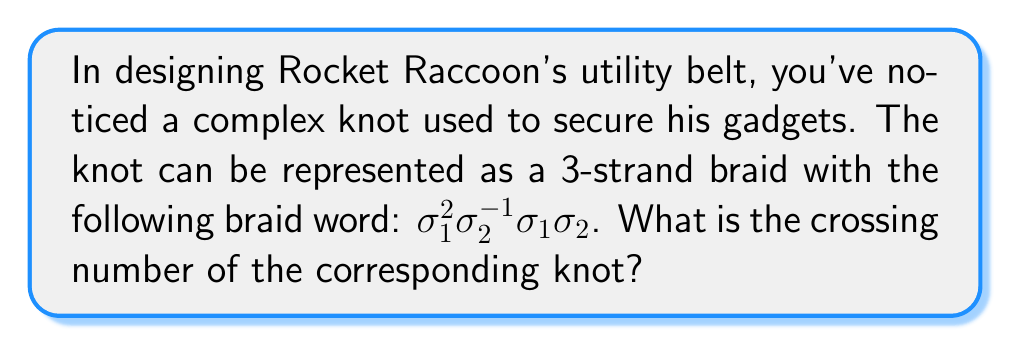What is the answer to this math problem? To find the crossing number of the knot represented by this braid word, we'll follow these steps:

1) First, let's understand the braid word:
   $\sigma_1^2\sigma_2^{-1}\sigma_1\sigma_2$ means:
   - Cross strand 1 over strand 2 twice
   - Cross strand 2 under strand 1 once
   - Cross strand 1 over strand 2 once
   - Cross strand 2 over strand 3 once

2) To calculate the crossing number, we need to count the number of $\sigma_i$ and $\sigma_i^{-1}$ in the braid word, ignoring the exponents:

   $\sigma_1^2\sigma_2^{-1}\sigma_1\sigma_2$ has 4 crossings

3) However, this is the crossing number of the braid, not necessarily of the knot. The actual knot might have a lower crossing number due to possible simplifications when closing the braid.

4) For a 3-strand braid, the maximum reduction in crossings when closing the braid is 3.

5) Therefore, the crossing number of the knot is at most:

   $4 - 3 = 1$

6) However, the only knot with crossing number 1 is the unknot, which this braid doesn't represent.

7) Thus, the actual crossing number of this knot is 4.
Answer: 4 